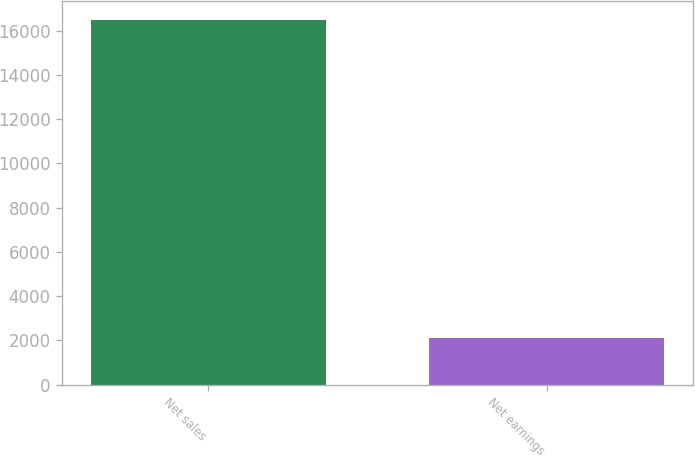Convert chart. <chart><loc_0><loc_0><loc_500><loc_500><bar_chart><fcel>Net sales<fcel>Net earnings<nl><fcel>16493<fcel>2123<nl></chart> 